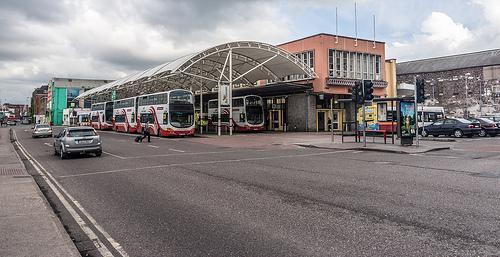How many buses are in the photo?
Give a very brief answer. 2. 